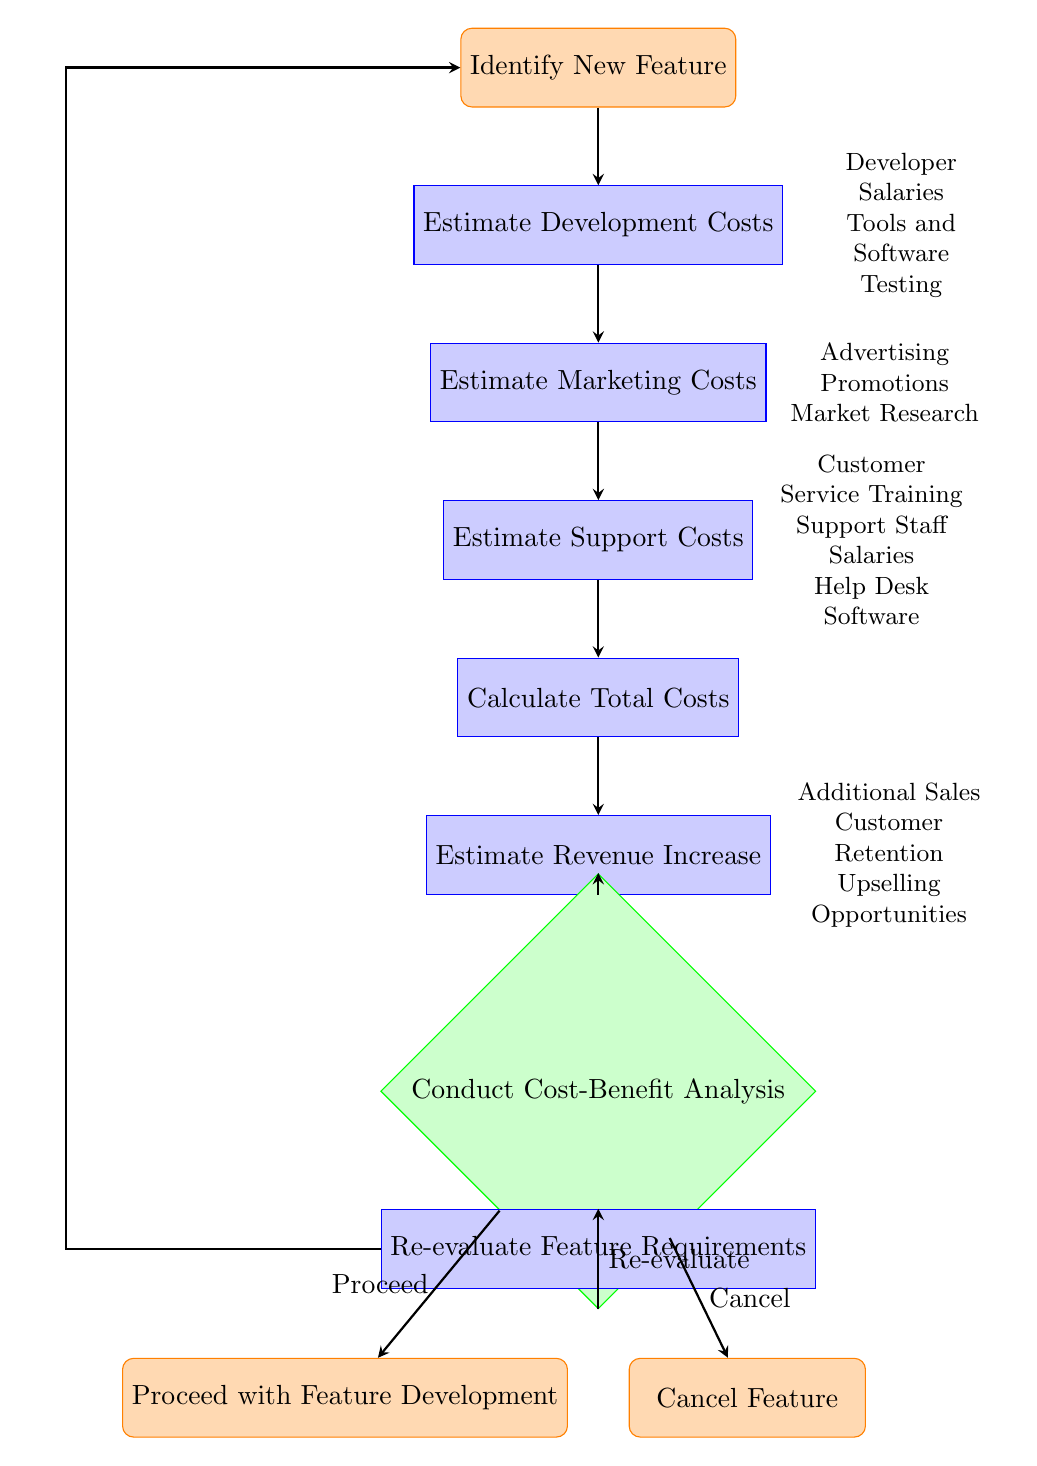What is the first step in the flow chart? The first step in the flow chart is labeled "Identify New Feature," which is the starting point before any other processes take place.
Answer: Identify New Feature How many total nodes are there in the diagram? By counting each distinct step or decision point in the flow chart, we find there are a total of ten nodes.
Answer: 10 Which node follows "Estimate Development Costs"? After "Estimate Development Costs," the next node is "Estimate Marketing Costs," as shown by the directional arrow connecting them.
Answer: Estimate Marketing Costs What costs are estimated in the third step? The third step, "Estimate Marketing Costs," refers to various expenses involved in marketing, specifically mentioned as advertising, promotions, and market research.
Answer: Advertising, Promotions, Market Research What is the outcome if the decision made is to "Cancel"? If the decision taken at the "Conduct Cost-Benefit Analysis" node is to "Cancel," the flow directs to the node labeled "Cancel Feature," which denotes the end of that trajectory.
Answer: Cancel Feature What leads to "Re-evaluate Feature Requirements"? The condition "Re-evaluate" from the "Conduct Cost-Benefit Analysis" node results in the process labeled "Re-evaluate Feature Requirements," indicating a need to reassess aspects of the feature before proceeding.
Answer: Re-evaluate Feature Requirements How are Total Costs calculated? Total Costs are calculated by aggregating Development Costs, Marketing Costs, and Support Costs, as indicated in the "Calculate Total Costs" node, which lists these sources directly.
Answer: Development Costs, Marketing Costs, Support Costs What factors are considered in estimating revenue increase? The factors mentioned in the node "Estimate Revenue Increase" include additional sales, customer retention, and upselling opportunities, which are key elements in projecting potential revenue uplift.
Answer: Additional Sales, Customer Retention, Upselling Opportunities What is the last node before the process decides whether to proceed, re-evaluate, or cancel? The last node before the decision on whether to proceed, re-evaluate, or cancel is the "Estimate Revenue Increase" node which provides information needed for the upcoming decision-making step.
Answer: Estimate Revenue Increase What decision options follow the "Conduct Cost-Benefit Analysis"? The options that follow the "Conduct Cost-Benefit Analysis" decision node are to either proceed, re-evaluate, or cancel, which illustrates the different paths that can be taken based on the analysis outcome.
Answer: Proceed, Re-evaluate, Cancel 